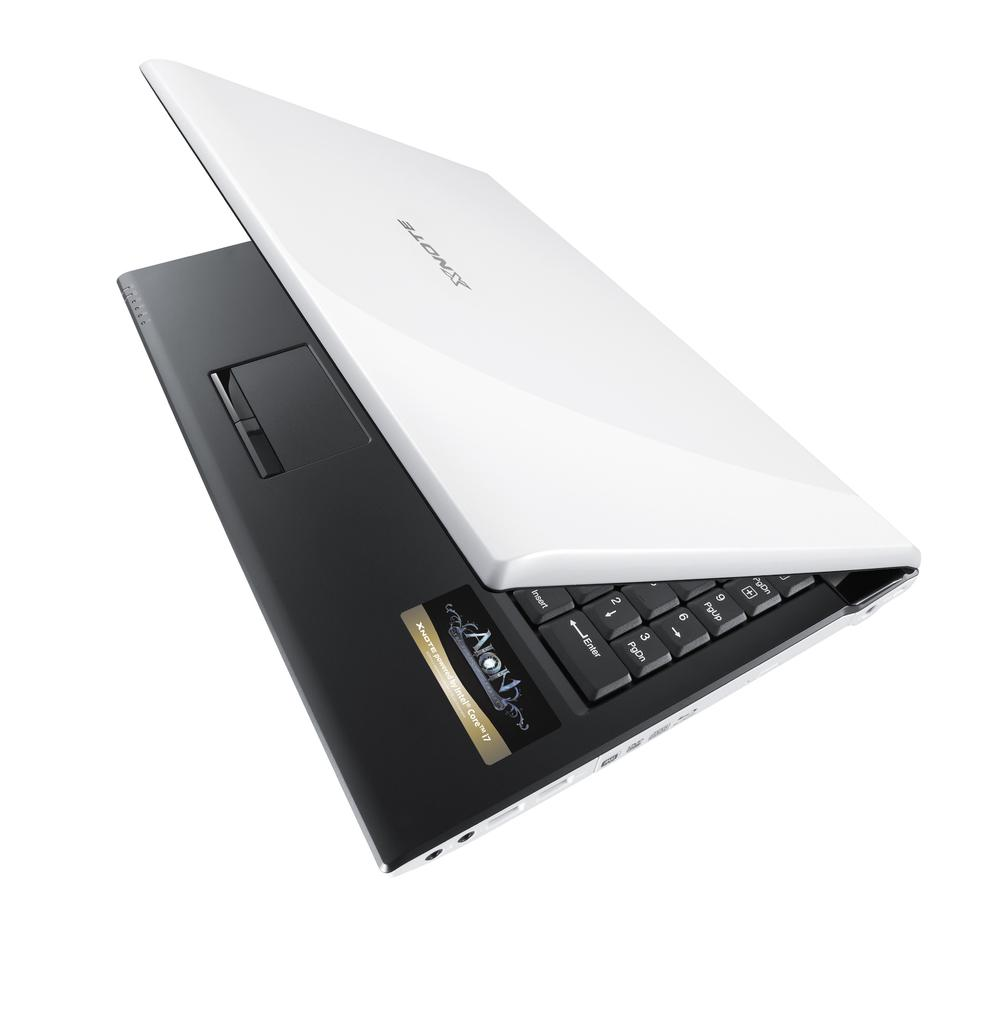<image>
Create a compact narrative representing the image presented. A white XNote brand laptop slightly opened with a black interior 